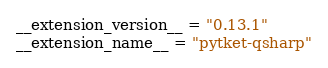Convert code to text. <code><loc_0><loc_0><loc_500><loc_500><_Python_>__extension_version__ = "0.13.1"
__extension_name__ = "pytket-qsharp"
</code> 